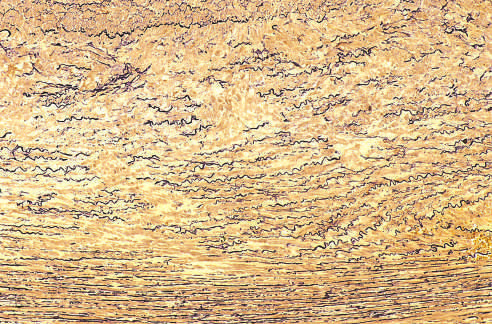what shows marked elastin fragmentation and areas devoid of elastin that resemble cystic spaces (asterisks)?
Answer the question using a single word or phrase. Cross-section of aortic media from a patient with marfan syndrome 